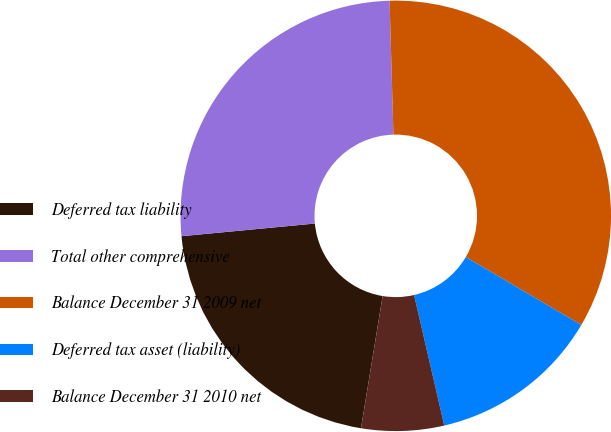Convert chart to OTSL. <chart><loc_0><loc_0><loc_500><loc_500><pie_chart><fcel>Deferred tax liability<fcel>Total other comprehensive<fcel>Balance December 31 2009 net<fcel>Deferred tax asset (liability)<fcel>Balance December 31 2010 net<nl><fcel>20.91%<fcel>26.05%<fcel>33.92%<fcel>12.92%<fcel>6.2%<nl></chart> 